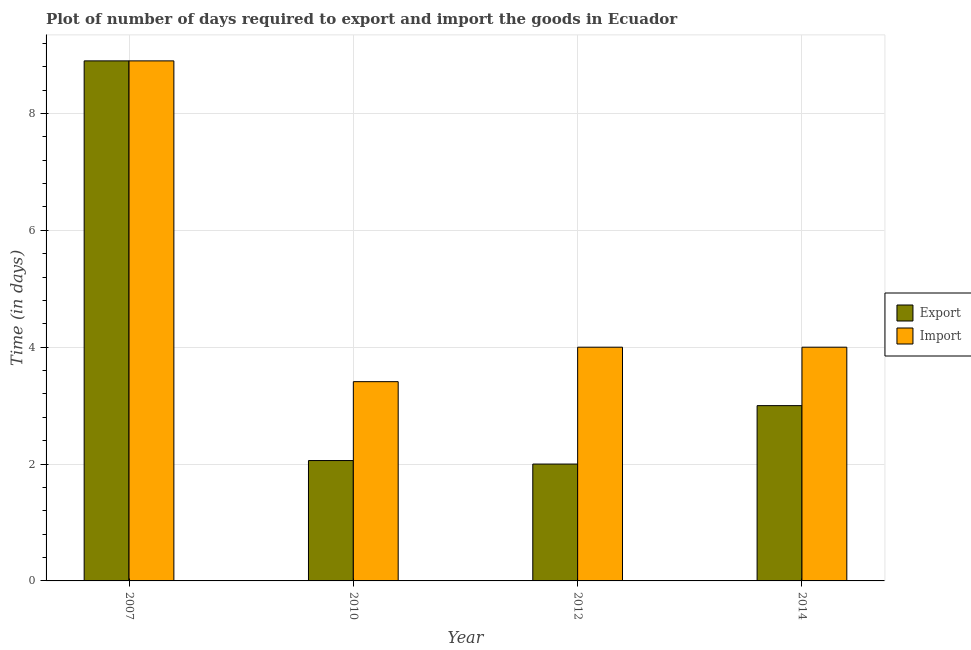How many groups of bars are there?
Give a very brief answer. 4. Are the number of bars per tick equal to the number of legend labels?
Make the answer very short. Yes. Are the number of bars on each tick of the X-axis equal?
Give a very brief answer. Yes. How many bars are there on the 1st tick from the left?
Your response must be concise. 2. What is the label of the 4th group of bars from the left?
Your response must be concise. 2014. In how many cases, is the number of bars for a given year not equal to the number of legend labels?
Your answer should be very brief. 0. Across all years, what is the maximum time required to import?
Keep it short and to the point. 8.9. Across all years, what is the minimum time required to export?
Provide a succinct answer. 2. In which year was the time required to import maximum?
Your answer should be very brief. 2007. In which year was the time required to export minimum?
Provide a short and direct response. 2012. What is the total time required to export in the graph?
Give a very brief answer. 15.96. What is the difference between the time required to import in 2007 and that in 2010?
Your response must be concise. 5.49. What is the difference between the time required to export in 2012 and the time required to import in 2010?
Keep it short and to the point. -0.06. What is the average time required to export per year?
Provide a succinct answer. 3.99. What is the ratio of the time required to import in 2007 to that in 2012?
Your answer should be compact. 2.23. Is the difference between the time required to import in 2007 and 2010 greater than the difference between the time required to export in 2007 and 2010?
Provide a succinct answer. No. What is the difference between the highest and the second highest time required to import?
Provide a short and direct response. 4.9. In how many years, is the time required to export greater than the average time required to export taken over all years?
Provide a succinct answer. 1. What does the 1st bar from the left in 2012 represents?
Provide a short and direct response. Export. What does the 2nd bar from the right in 2007 represents?
Make the answer very short. Export. Are all the bars in the graph horizontal?
Offer a very short reply. No. How many years are there in the graph?
Ensure brevity in your answer.  4. Are the values on the major ticks of Y-axis written in scientific E-notation?
Ensure brevity in your answer.  No. Where does the legend appear in the graph?
Ensure brevity in your answer.  Center right. How are the legend labels stacked?
Offer a terse response. Vertical. What is the title of the graph?
Keep it short and to the point. Plot of number of days required to export and import the goods in Ecuador. Does "Not attending school" appear as one of the legend labels in the graph?
Offer a terse response. No. What is the label or title of the X-axis?
Make the answer very short. Year. What is the label or title of the Y-axis?
Give a very brief answer. Time (in days). What is the Time (in days) in Export in 2010?
Your response must be concise. 2.06. What is the Time (in days) in Import in 2010?
Give a very brief answer. 3.41. What is the Time (in days) of Export in 2012?
Keep it short and to the point. 2. What is the Time (in days) in Import in 2012?
Offer a terse response. 4. What is the Time (in days) of Export in 2014?
Your response must be concise. 3. What is the Time (in days) of Import in 2014?
Provide a short and direct response. 4. Across all years, what is the maximum Time (in days) in Export?
Ensure brevity in your answer.  8.9. Across all years, what is the maximum Time (in days) in Import?
Give a very brief answer. 8.9. Across all years, what is the minimum Time (in days) in Import?
Your answer should be compact. 3.41. What is the total Time (in days) in Export in the graph?
Make the answer very short. 15.96. What is the total Time (in days) of Import in the graph?
Make the answer very short. 20.31. What is the difference between the Time (in days) of Export in 2007 and that in 2010?
Your answer should be very brief. 6.84. What is the difference between the Time (in days) of Import in 2007 and that in 2010?
Offer a terse response. 5.49. What is the difference between the Time (in days) in Export in 2007 and that in 2012?
Make the answer very short. 6.9. What is the difference between the Time (in days) of Import in 2007 and that in 2012?
Make the answer very short. 4.9. What is the difference between the Time (in days) of Export in 2007 and that in 2014?
Your answer should be compact. 5.9. What is the difference between the Time (in days) of Import in 2007 and that in 2014?
Your response must be concise. 4.9. What is the difference between the Time (in days) in Export in 2010 and that in 2012?
Keep it short and to the point. 0.06. What is the difference between the Time (in days) in Import in 2010 and that in 2012?
Offer a very short reply. -0.59. What is the difference between the Time (in days) of Export in 2010 and that in 2014?
Offer a terse response. -0.94. What is the difference between the Time (in days) in Import in 2010 and that in 2014?
Give a very brief answer. -0.59. What is the difference between the Time (in days) of Export in 2007 and the Time (in days) of Import in 2010?
Ensure brevity in your answer.  5.49. What is the difference between the Time (in days) of Export in 2010 and the Time (in days) of Import in 2012?
Your response must be concise. -1.94. What is the difference between the Time (in days) in Export in 2010 and the Time (in days) in Import in 2014?
Offer a terse response. -1.94. What is the difference between the Time (in days) of Export in 2012 and the Time (in days) of Import in 2014?
Offer a terse response. -2. What is the average Time (in days) of Export per year?
Your response must be concise. 3.99. What is the average Time (in days) of Import per year?
Offer a terse response. 5.08. In the year 2010, what is the difference between the Time (in days) of Export and Time (in days) of Import?
Give a very brief answer. -1.35. In the year 2012, what is the difference between the Time (in days) in Export and Time (in days) in Import?
Provide a short and direct response. -2. In the year 2014, what is the difference between the Time (in days) in Export and Time (in days) in Import?
Keep it short and to the point. -1. What is the ratio of the Time (in days) of Export in 2007 to that in 2010?
Provide a short and direct response. 4.32. What is the ratio of the Time (in days) in Import in 2007 to that in 2010?
Provide a succinct answer. 2.61. What is the ratio of the Time (in days) of Export in 2007 to that in 2012?
Offer a very short reply. 4.45. What is the ratio of the Time (in days) of Import in 2007 to that in 2012?
Ensure brevity in your answer.  2.23. What is the ratio of the Time (in days) in Export in 2007 to that in 2014?
Offer a terse response. 2.97. What is the ratio of the Time (in days) of Import in 2007 to that in 2014?
Make the answer very short. 2.23. What is the ratio of the Time (in days) in Export in 2010 to that in 2012?
Offer a very short reply. 1.03. What is the ratio of the Time (in days) of Import in 2010 to that in 2012?
Offer a very short reply. 0.85. What is the ratio of the Time (in days) in Export in 2010 to that in 2014?
Provide a succinct answer. 0.69. What is the ratio of the Time (in days) of Import in 2010 to that in 2014?
Your answer should be compact. 0.85. What is the ratio of the Time (in days) in Export in 2012 to that in 2014?
Offer a very short reply. 0.67. What is the ratio of the Time (in days) in Import in 2012 to that in 2014?
Provide a succinct answer. 1. What is the difference between the highest and the lowest Time (in days) of Import?
Offer a very short reply. 5.49. 